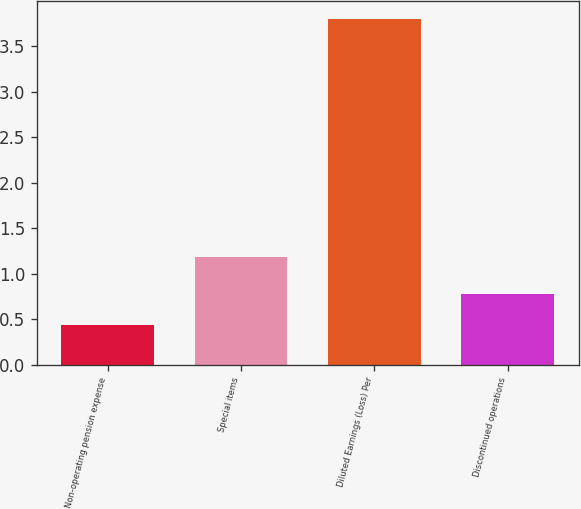<chart> <loc_0><loc_0><loc_500><loc_500><bar_chart><fcel>Non-operating pension expense<fcel>Special items<fcel>Diluted Earnings (Loss) Per<fcel>Discontinued operations<nl><fcel>0.44<fcel>1.18<fcel>3.8<fcel>0.78<nl></chart> 